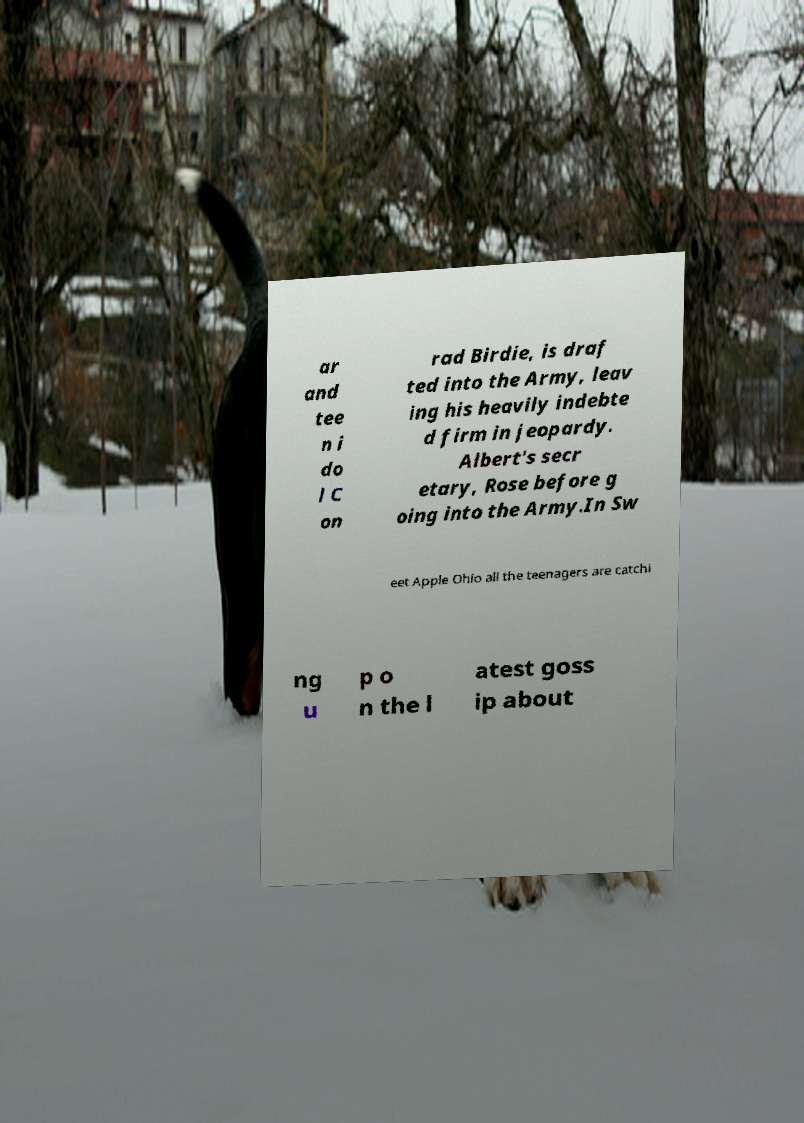Please identify and transcribe the text found in this image. ar and tee n i do l C on rad Birdie, is draf ted into the Army, leav ing his heavily indebte d firm in jeopardy. Albert's secr etary, Rose before g oing into the Army.In Sw eet Apple Ohio all the teenagers are catchi ng u p o n the l atest goss ip about 